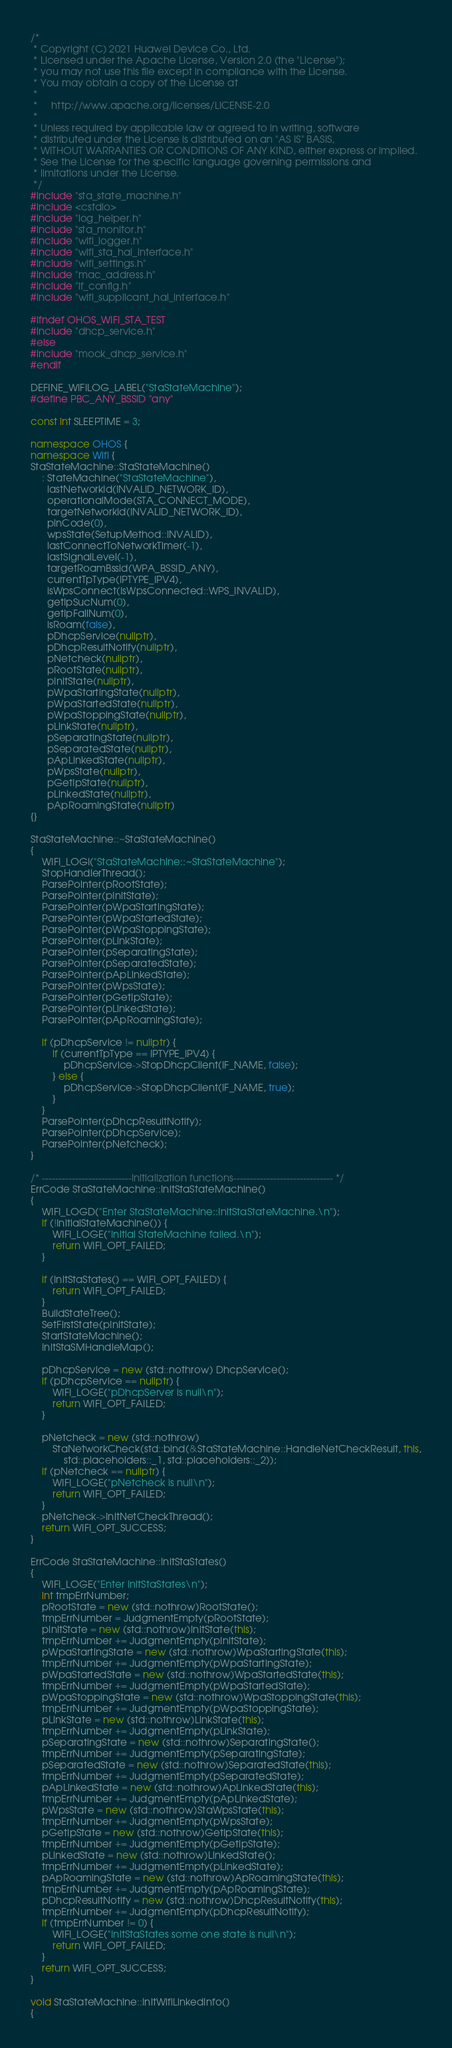<code> <loc_0><loc_0><loc_500><loc_500><_C++_>/*
 * Copyright (C) 2021 Huawei Device Co., Ltd.
 * Licensed under the Apache License, Version 2.0 (the "License");
 * you may not use this file except in compliance with the License.
 * You may obtain a copy of the License at
 *
 *     http://www.apache.org/licenses/LICENSE-2.0
 *
 * Unless required by applicable law or agreed to in writing, software
 * distributed under the License is distributed on an "AS IS" BASIS,
 * WITHOUT WARRANTIES OR CONDITIONS OF ANY KIND, either express or implied.
 * See the License for the specific language governing permissions and
 * limitations under the License.
 */
#include "sta_state_machine.h"
#include <cstdio>
#include "log_helper.h"
#include "sta_monitor.h"
#include "wifi_logger.h"
#include "wifi_sta_hal_interface.h"
#include "wifi_settings.h"
#include "mac_address.h"
#include "if_config.h"
#include "wifi_supplicant_hal_interface.h"

#ifndef OHOS_WIFI_STA_TEST
#include "dhcp_service.h"
#else
#include "mock_dhcp_service.h"
#endif

DEFINE_WIFILOG_LABEL("StaStateMachine");
#define PBC_ANY_BSSID "any"

const int SLEEPTIME = 3;

namespace OHOS {
namespace Wifi {
StaStateMachine::StaStateMachine()
    : StateMachine("StaStateMachine"),
      lastNetworkId(INVALID_NETWORK_ID),
      operationalMode(STA_CONNECT_MODE),
      targetNetworkId(INVALID_NETWORK_ID),
      pinCode(0),
      wpsState(SetupMethod::INVALID),
      lastConnectToNetworkTimer(-1),
      lastSignalLevel(-1),
      targetRoamBssid(WPA_BSSID_ANY),
      currentTpType(IPTYPE_IPV4),
      isWpsConnect(IsWpsConnected::WPS_INVALID),
      getIpSucNum(0),
      getIpFailNum(0),
      isRoam(false),
      pDhcpService(nullptr),
      pDhcpResultNotify(nullptr),
      pNetcheck(nullptr),
      pRootState(nullptr),
      pInitState(nullptr),
      pWpaStartingState(nullptr),
      pWpaStartedState(nullptr),
      pWpaStoppingState(nullptr),
      pLinkState(nullptr),
      pSeparatingState(nullptr),
      pSeparatedState(nullptr),
      pApLinkedState(nullptr),
      pWpsState(nullptr),
      pGetIpState(nullptr),
      pLinkedState(nullptr),
      pApRoamingState(nullptr)
{}

StaStateMachine::~StaStateMachine()
{
    WIFI_LOGI("StaStateMachine::~StaStateMachine");
    StopHandlerThread();
    ParsePointer(pRootState);
    ParsePointer(pInitState);
    ParsePointer(pWpaStartingState);
    ParsePointer(pWpaStartedState);
    ParsePointer(pWpaStoppingState);
    ParsePointer(pLinkState);
    ParsePointer(pSeparatingState);
    ParsePointer(pSeparatedState);
    ParsePointer(pApLinkedState);
    ParsePointer(pWpsState);
    ParsePointer(pGetIpState);
    ParsePointer(pLinkedState);
    ParsePointer(pApRoamingState);

    if (pDhcpService != nullptr) {
        if (currentTpType == IPTYPE_IPV4) {
            pDhcpService->StopDhcpClient(IF_NAME, false);
        } else {
            pDhcpService->StopDhcpClient(IF_NAME, true);
        }
    }
    ParsePointer(pDhcpResultNotify);
    ParsePointer(pDhcpService);
    ParsePointer(pNetcheck);
}

/* ---------------------------Initialization functions------------------------------ */
ErrCode StaStateMachine::InitStaStateMachine()
{
    WIFI_LOGD("Enter StaStateMachine::InitStaStateMachine.\n");
    if (!InitialStateMachine()) {
        WIFI_LOGE("Initial StateMachine failed.\n");
        return WIFI_OPT_FAILED;
    }

    if (InitStaStates() == WIFI_OPT_FAILED) {
        return WIFI_OPT_FAILED;
    }
    BuildStateTree();
    SetFirstState(pInitState);
    StartStateMachine();
    InitStaSMHandleMap();

    pDhcpService = new (std::nothrow) DhcpService();
    if (pDhcpService == nullptr) {
        WIFI_LOGE("pDhcpServer is null\n");
        return WIFI_OPT_FAILED;
    }

    pNetcheck = new (std::nothrow)
        StaNetworkCheck(std::bind(&StaStateMachine::HandleNetCheckResult, this,
            std::placeholders::_1, std::placeholders::_2));
    if (pNetcheck == nullptr) {
        WIFI_LOGE("pNetcheck is null\n");
        return WIFI_OPT_FAILED;
    }
    pNetcheck->InitNetCheckThread();
    return WIFI_OPT_SUCCESS;
}

ErrCode StaStateMachine::InitStaStates()
{
    WIFI_LOGE("Enter InitStaStates\n");
    int tmpErrNumber;
    pRootState = new (std::nothrow)RootState();
    tmpErrNumber = JudgmentEmpty(pRootState);
    pInitState = new (std::nothrow)InitState(this);
    tmpErrNumber += JudgmentEmpty(pInitState);
    pWpaStartingState = new (std::nothrow)WpaStartingState(this);
    tmpErrNumber += JudgmentEmpty(pWpaStartingState);
    pWpaStartedState = new (std::nothrow)WpaStartedState(this);
    tmpErrNumber += JudgmentEmpty(pWpaStartedState);
    pWpaStoppingState = new (std::nothrow)WpaStoppingState(this);
    tmpErrNumber += JudgmentEmpty(pWpaStoppingState);
    pLinkState = new (std::nothrow)LinkState(this);
    tmpErrNumber += JudgmentEmpty(pLinkState);
    pSeparatingState = new (std::nothrow)SeparatingState();
    tmpErrNumber += JudgmentEmpty(pSeparatingState);
    pSeparatedState = new (std::nothrow)SeparatedState(this);
    tmpErrNumber += JudgmentEmpty(pSeparatedState);
    pApLinkedState = new (std::nothrow)ApLinkedState(this);
    tmpErrNumber += JudgmentEmpty(pApLinkedState);
    pWpsState = new (std::nothrow)StaWpsState(this);
    tmpErrNumber += JudgmentEmpty(pWpsState);
    pGetIpState = new (std::nothrow)GetIpState(this);
    tmpErrNumber += JudgmentEmpty(pGetIpState);
    pLinkedState = new (std::nothrow)LinkedState();
    tmpErrNumber += JudgmentEmpty(pLinkedState);
    pApRoamingState = new (std::nothrow)ApRoamingState(this);
    tmpErrNumber += JudgmentEmpty(pApRoamingState);
    pDhcpResultNotify = new (std::nothrow)DhcpResultNotify(this);
    tmpErrNumber += JudgmentEmpty(pDhcpResultNotify);
    if (tmpErrNumber != 0) {
        WIFI_LOGE("InitStaStates some one state is null\n");
        return WIFI_OPT_FAILED;
    }
    return WIFI_OPT_SUCCESS;
}

void StaStateMachine::InitWifiLinkedInfo()
{</code> 